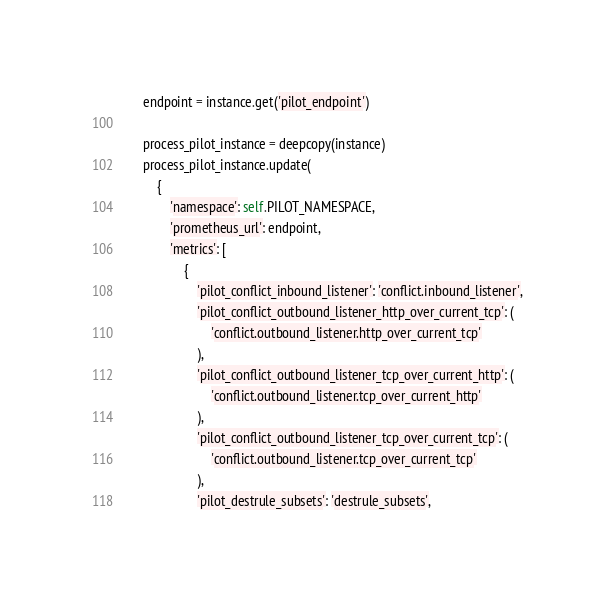Convert code to text. <code><loc_0><loc_0><loc_500><loc_500><_Python_>        endpoint = instance.get('pilot_endpoint')

        process_pilot_instance = deepcopy(instance)
        process_pilot_instance.update(
            {
                'namespace': self.PILOT_NAMESPACE,
                'prometheus_url': endpoint,
                'metrics': [
                    {
                        'pilot_conflict_inbound_listener': 'conflict.inbound_listener',
                        'pilot_conflict_outbound_listener_http_over_current_tcp': (
                            'conflict.outbound_listener.http_over_current_tcp'
                        ),
                        'pilot_conflict_outbound_listener_tcp_over_current_http': (
                            'conflict.outbound_listener.tcp_over_current_http'
                        ),
                        'pilot_conflict_outbound_listener_tcp_over_current_tcp': (
                            'conflict.outbound_listener.tcp_over_current_tcp'
                        ),
                        'pilot_destrule_subsets': 'destrule_subsets',</code> 